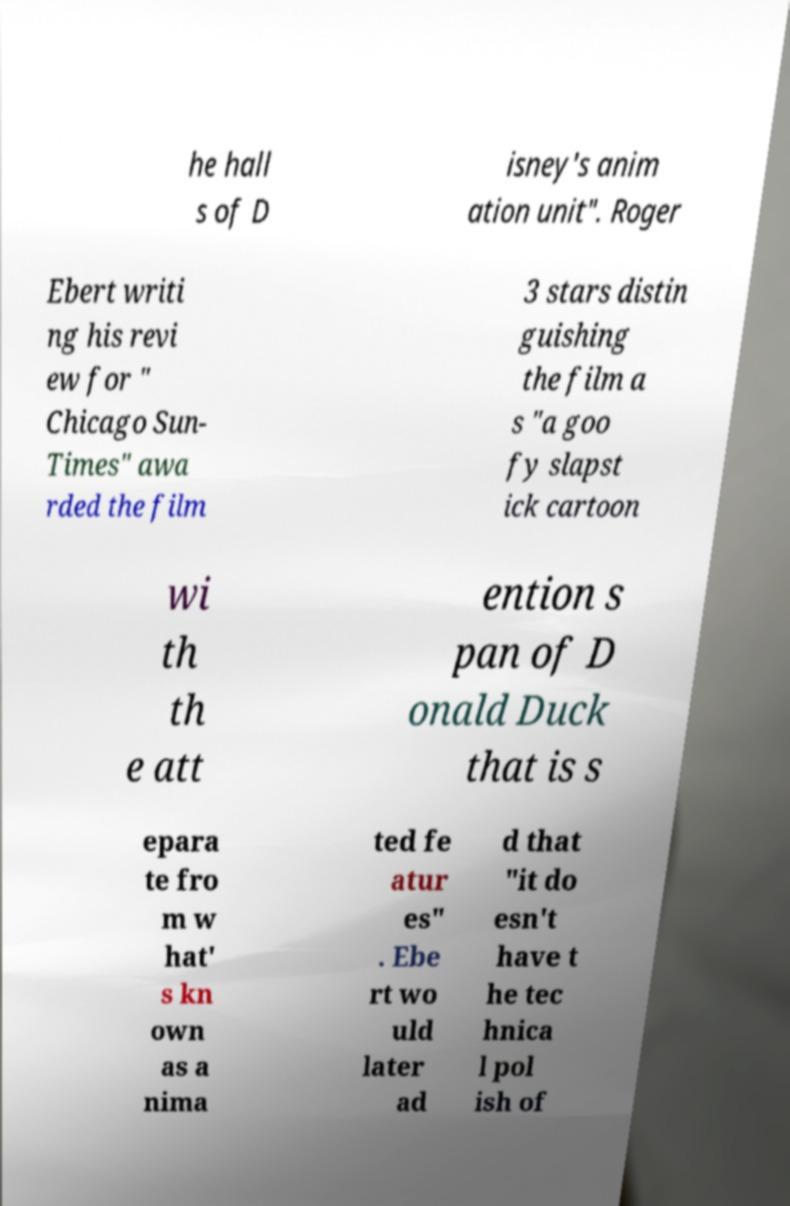Can you accurately transcribe the text from the provided image for me? he hall s of D isney's anim ation unit". Roger Ebert writi ng his revi ew for " Chicago Sun- Times" awa rded the film 3 stars distin guishing the film a s "a goo fy slapst ick cartoon wi th th e att ention s pan of D onald Duck that is s epara te fro m w hat' s kn own as a nima ted fe atur es" . Ebe rt wo uld later ad d that "it do esn't have t he tec hnica l pol ish of 